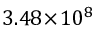<formula> <loc_0><loc_0><loc_500><loc_500>3 . 4 8 \, \times \, 1 0 ^ { 8 }</formula> 